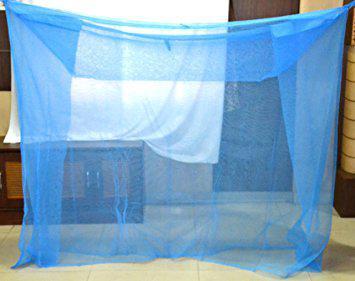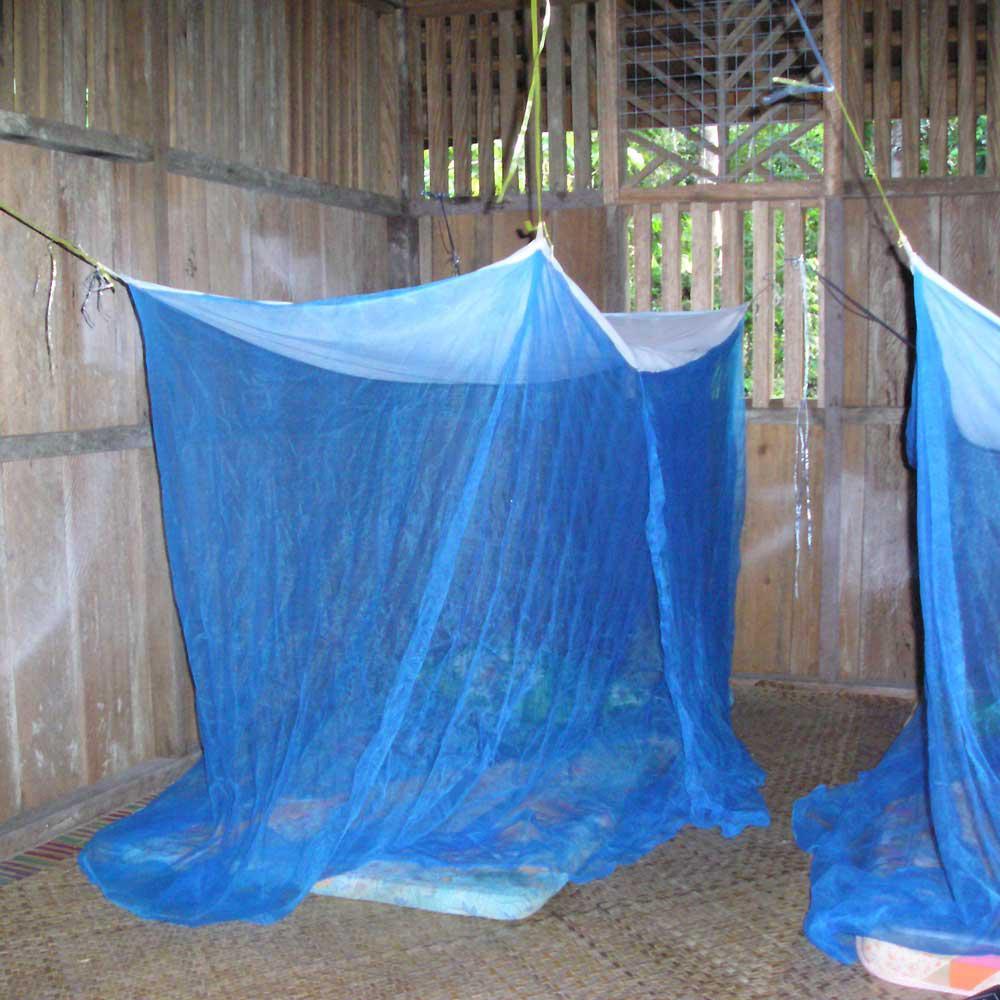The first image is the image on the left, the second image is the image on the right. For the images displayed, is the sentence "The bed draperies in each image are similar in color and suspended from a circular framework over the bed." factually correct? Answer yes or no. No. The first image is the image on the left, the second image is the image on the right. Considering the images on both sides, is "All the nets are blue." valid? Answer yes or no. Yes. 